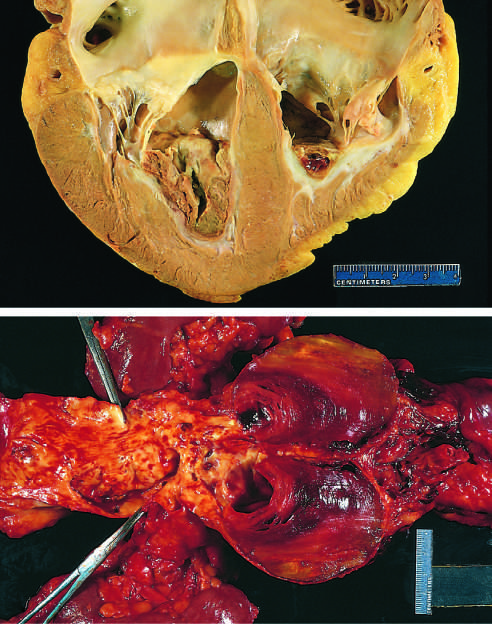what does thrombus in the left and right ventricular apices overlie?
Answer the question using a single word or phrase. White fibrous scar 